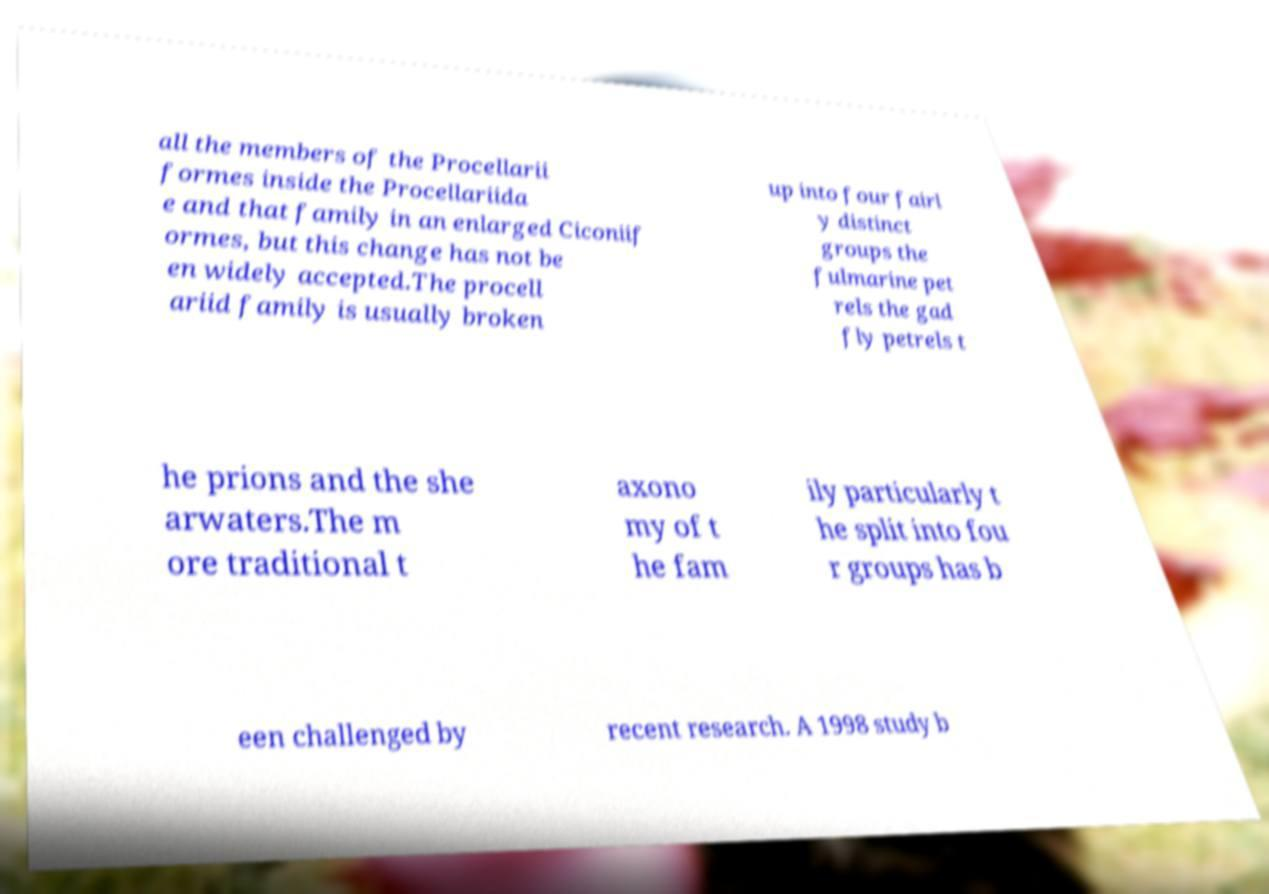Can you read and provide the text displayed in the image?This photo seems to have some interesting text. Can you extract and type it out for me? all the members of the Procellarii formes inside the Procellariida e and that family in an enlarged Ciconiif ormes, but this change has not be en widely accepted.The procell ariid family is usually broken up into four fairl y distinct groups the fulmarine pet rels the gad fly petrels t he prions and the she arwaters.The m ore traditional t axono my of t he fam ily particularly t he split into fou r groups has b een challenged by recent research. A 1998 study b 